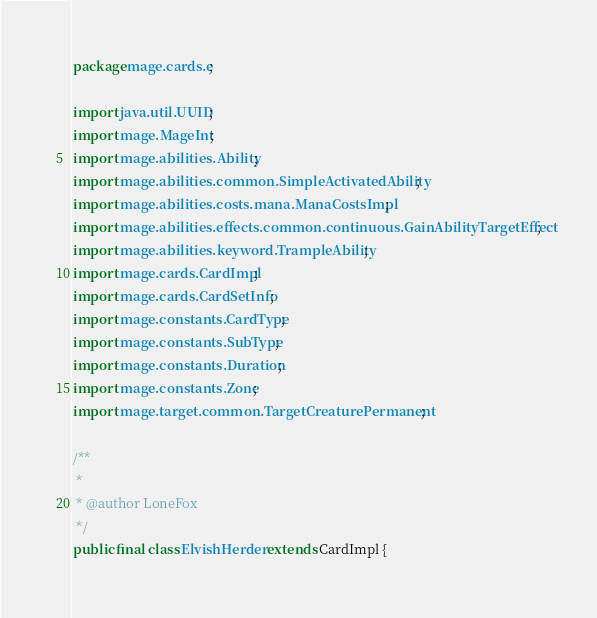Convert code to text. <code><loc_0><loc_0><loc_500><loc_500><_Java_>package mage.cards.e;

import java.util.UUID;
import mage.MageInt;
import mage.abilities.Ability;
import mage.abilities.common.SimpleActivatedAbility;
import mage.abilities.costs.mana.ManaCostsImpl;
import mage.abilities.effects.common.continuous.GainAbilityTargetEffect;
import mage.abilities.keyword.TrampleAbility;
import mage.cards.CardImpl;
import mage.cards.CardSetInfo;
import mage.constants.CardType;
import mage.constants.SubType;
import mage.constants.Duration;
import mage.constants.Zone;
import mage.target.common.TargetCreaturePermanent;

/**
 *
 * @author LoneFox
 */
public final class ElvishHerder extends CardImpl {
</code> 